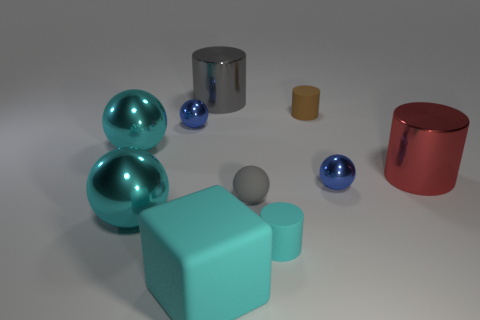Can you describe the lighting in the scene? The lighting in the image seems soft and diffused, with shadows cast subtly beneath each object, indicating a source of light that might be overhead and perhaps slightly to the front. 